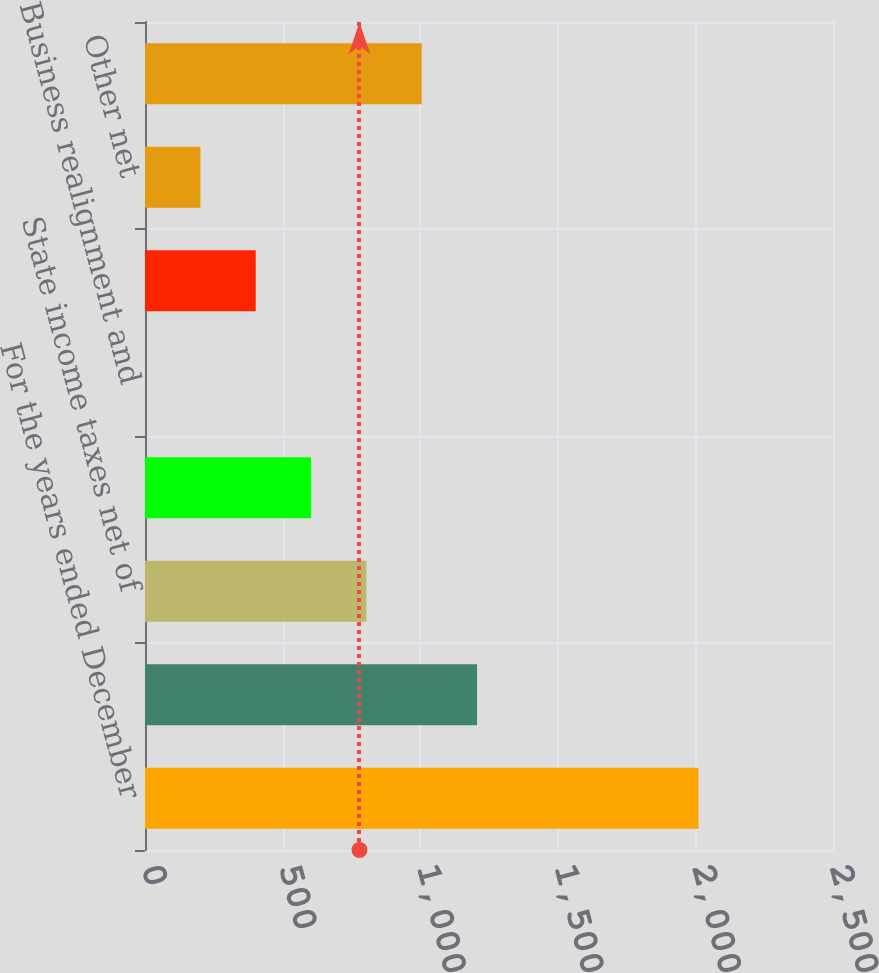<chart> <loc_0><loc_0><loc_500><loc_500><bar_chart><fcel>For the years ended December<fcel>Federal statutory income tax<fcel>State income taxes net of<fcel>Qualified production income<fcel>Business realignment and<fcel>International operations<fcel>Other net<fcel>Effective income tax rate<nl><fcel>2011<fcel>1206.64<fcel>804.46<fcel>603.37<fcel>0.1<fcel>402.28<fcel>201.19<fcel>1005.55<nl></chart> 